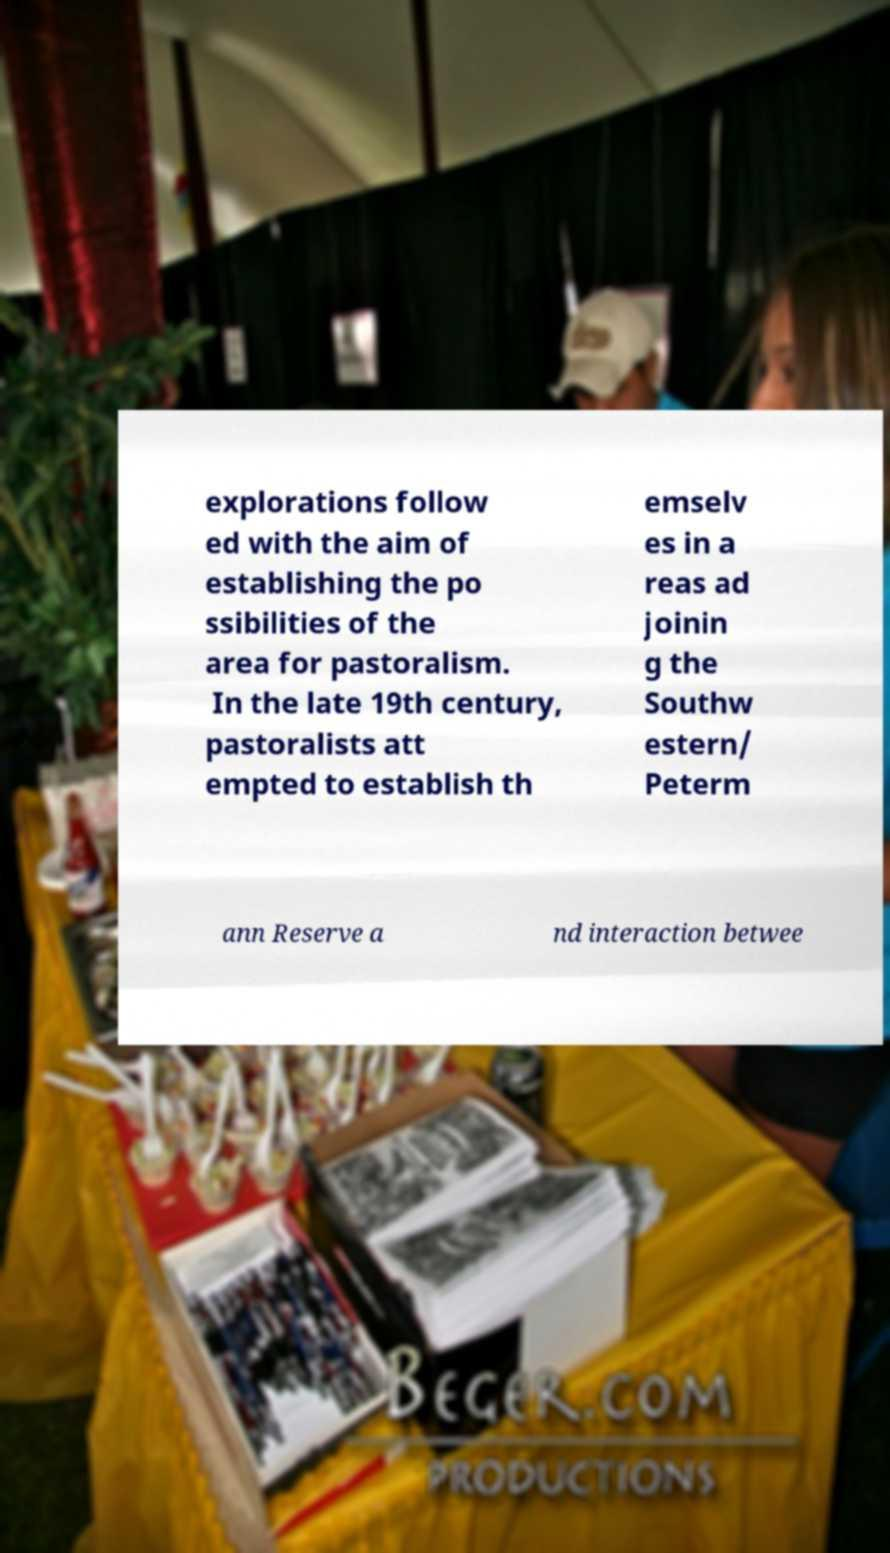Can you accurately transcribe the text from the provided image for me? explorations follow ed with the aim of establishing the po ssibilities of the area for pastoralism. In the late 19th century, pastoralists att empted to establish th emselv es in a reas ad joinin g the Southw estern/ Peterm ann Reserve a nd interaction betwee 